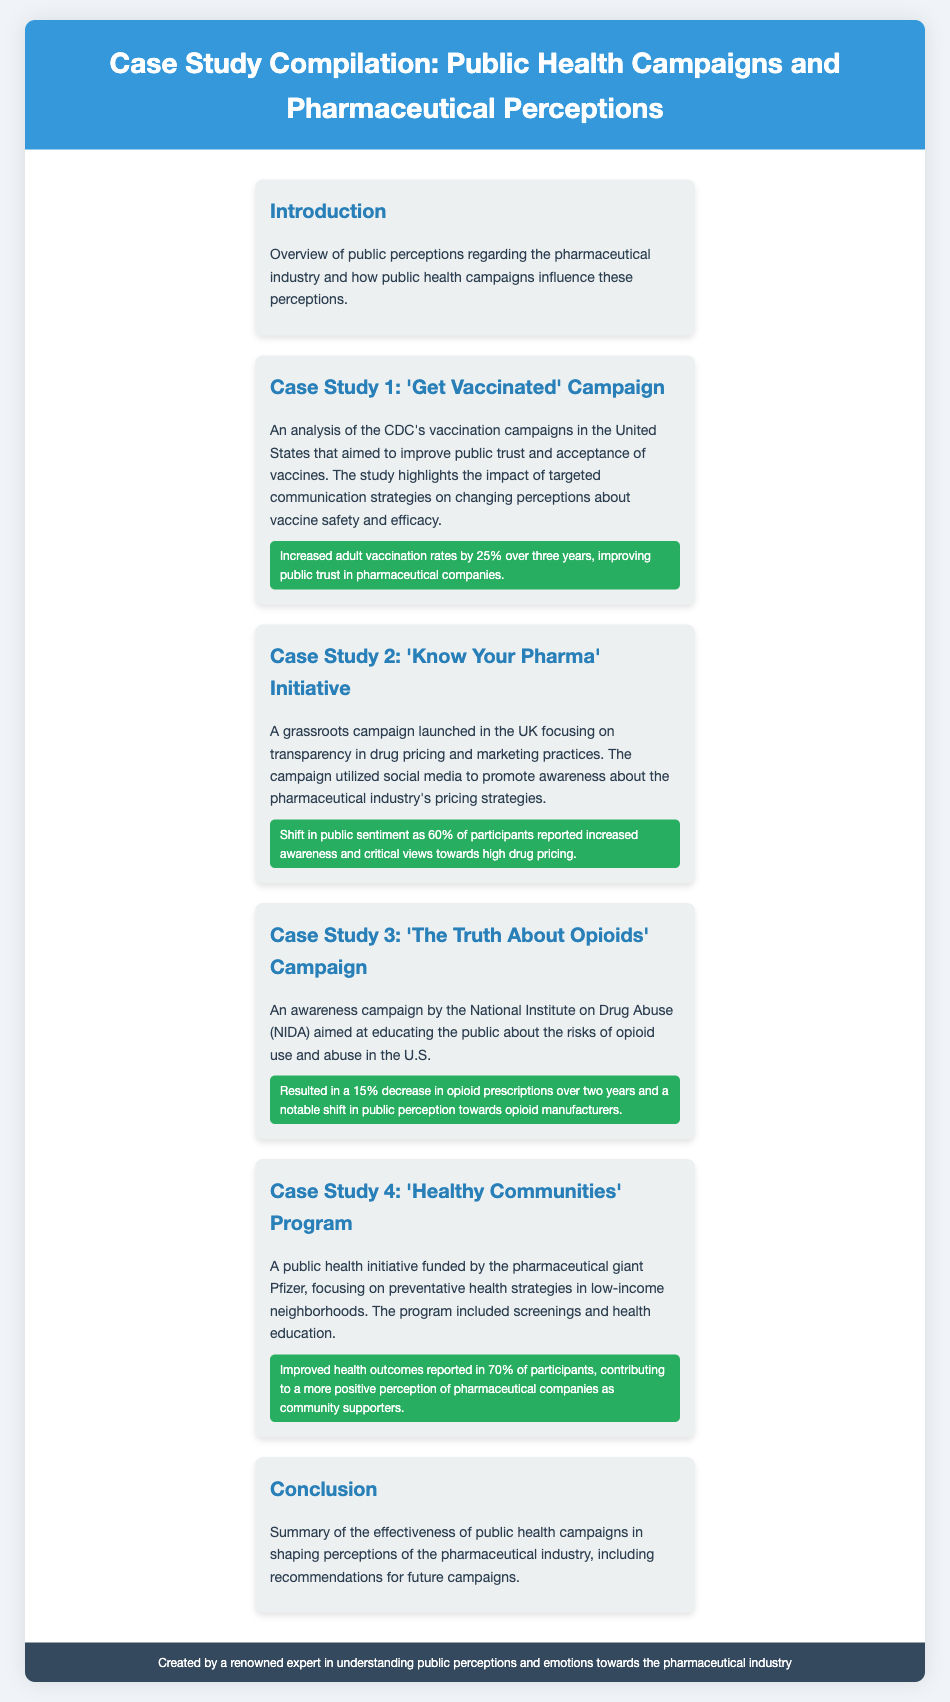what is the title of the case study compilation? The title is specified at the top of the document under the header section.
Answer: Case Study Compilation: Public Health Campaigns and Pharmaceutical Perceptions what campaign did the CDC conduct? The document mentions a specific campaign linked to the CDC aimed at improving public trust in vaccines.
Answer: 'Get Vaccinated' Campaign how much did vaccination rates increase in the 'Get Vaccinated' campaign? It refers to a specific percentage increase in vaccination rates as noted in the effectiveness section of that case study.
Answer: 25% what percentage of participants in the 'Know Your Pharma' initiative reported increased awareness? The document provides a statistic regarding the awareness of participants regarding drug pricing in this initiative.
Answer: 60% which company funded the 'Healthy Communities' Program? The document states the name of the pharmaceutical giant that funded this public health initiative.
Answer: Pfizer how much did opioid prescriptions decrease as a result of 'The Truth About Opioids' campaign? This detail is presented under the effectiveness section of the respective case study, focusing on prescription trends.
Answer: 15% which campaign aimed to educate the public about opioid risks? The document specifies the campaign focused on opioid education and its goals.
Answer: 'The Truth About Opioids' Campaign what type of initiatives are mentioned in the document? The document outlines various campaigns and initiatives aimed at changing perceptions towards the pharmaceutical industry.
Answer: Public health initiatives what is the main focus of the 'Healthy Communities' Program? The document explains the goals and focus of this particular public health initiative.
Answer: Preventative health strategies 